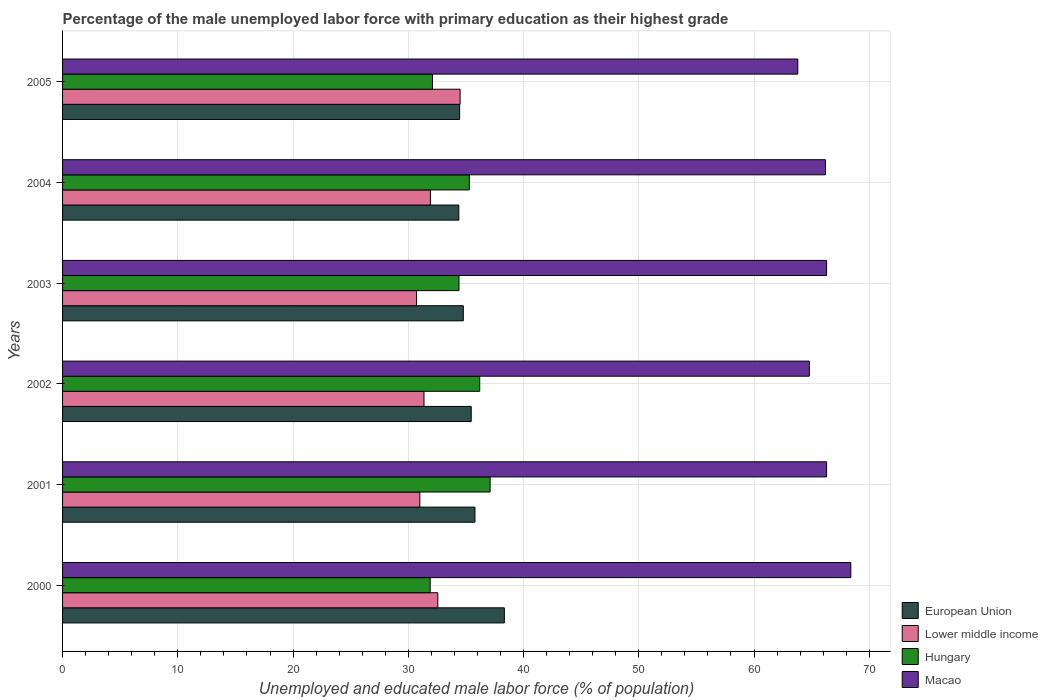How many groups of bars are there?
Keep it short and to the point. 6. Are the number of bars on each tick of the Y-axis equal?
Your response must be concise. Yes. How many bars are there on the 5th tick from the top?
Keep it short and to the point. 4. How many bars are there on the 3rd tick from the bottom?
Give a very brief answer. 4. What is the percentage of the unemployed male labor force with primary education in Hungary in 2000?
Provide a short and direct response. 31.9. Across all years, what is the maximum percentage of the unemployed male labor force with primary education in Macao?
Offer a terse response. 68.4. Across all years, what is the minimum percentage of the unemployed male labor force with primary education in Hungary?
Keep it short and to the point. 31.9. In which year was the percentage of the unemployed male labor force with primary education in Hungary maximum?
Ensure brevity in your answer.  2001. In which year was the percentage of the unemployed male labor force with primary education in Lower middle income minimum?
Offer a very short reply. 2003. What is the total percentage of the unemployed male labor force with primary education in Hungary in the graph?
Ensure brevity in your answer.  207. What is the difference between the percentage of the unemployed male labor force with primary education in Hungary in 2002 and that in 2004?
Give a very brief answer. 0.9. What is the difference between the percentage of the unemployed male labor force with primary education in Lower middle income in 2000 and the percentage of the unemployed male labor force with primary education in Hungary in 2003?
Your response must be concise. -1.84. What is the average percentage of the unemployed male labor force with primary education in Macao per year?
Your response must be concise. 65.97. In the year 2001, what is the difference between the percentage of the unemployed male labor force with primary education in European Union and percentage of the unemployed male labor force with primary education in Macao?
Provide a succinct answer. -30.51. What is the ratio of the percentage of the unemployed male labor force with primary education in Hungary in 2000 to that in 2005?
Your response must be concise. 0.99. What is the difference between the highest and the second highest percentage of the unemployed male labor force with primary education in Macao?
Give a very brief answer. 2.1. What is the difference between the highest and the lowest percentage of the unemployed male labor force with primary education in Hungary?
Provide a succinct answer. 5.2. In how many years, is the percentage of the unemployed male labor force with primary education in European Union greater than the average percentage of the unemployed male labor force with primary education in European Union taken over all years?
Offer a very short reply. 2. Is it the case that in every year, the sum of the percentage of the unemployed male labor force with primary education in European Union and percentage of the unemployed male labor force with primary education in Macao is greater than the sum of percentage of the unemployed male labor force with primary education in Lower middle income and percentage of the unemployed male labor force with primary education in Hungary?
Your answer should be compact. No. What does the 3rd bar from the top in 2000 represents?
Your answer should be very brief. Lower middle income. What does the 4th bar from the bottom in 2004 represents?
Keep it short and to the point. Macao. Are all the bars in the graph horizontal?
Give a very brief answer. Yes. How many years are there in the graph?
Give a very brief answer. 6. Are the values on the major ticks of X-axis written in scientific E-notation?
Keep it short and to the point. No. What is the title of the graph?
Your response must be concise. Percentage of the male unemployed labor force with primary education as their highest grade. Does "Niger" appear as one of the legend labels in the graph?
Your answer should be compact. No. What is the label or title of the X-axis?
Your answer should be very brief. Unemployed and educated male labor force (% of population). What is the label or title of the Y-axis?
Your response must be concise. Years. What is the Unemployed and educated male labor force (% of population) of European Union in 2000?
Your answer should be very brief. 38.34. What is the Unemployed and educated male labor force (% of population) of Lower middle income in 2000?
Provide a succinct answer. 32.56. What is the Unemployed and educated male labor force (% of population) of Hungary in 2000?
Your response must be concise. 31.9. What is the Unemployed and educated male labor force (% of population) in Macao in 2000?
Give a very brief answer. 68.4. What is the Unemployed and educated male labor force (% of population) of European Union in 2001?
Give a very brief answer. 35.79. What is the Unemployed and educated male labor force (% of population) of Lower middle income in 2001?
Keep it short and to the point. 31. What is the Unemployed and educated male labor force (% of population) of Hungary in 2001?
Make the answer very short. 37.1. What is the Unemployed and educated male labor force (% of population) in Macao in 2001?
Ensure brevity in your answer.  66.3. What is the Unemployed and educated male labor force (% of population) in European Union in 2002?
Your answer should be compact. 35.46. What is the Unemployed and educated male labor force (% of population) of Lower middle income in 2002?
Ensure brevity in your answer.  31.36. What is the Unemployed and educated male labor force (% of population) in Hungary in 2002?
Keep it short and to the point. 36.2. What is the Unemployed and educated male labor force (% of population) in Macao in 2002?
Your response must be concise. 64.8. What is the Unemployed and educated male labor force (% of population) in European Union in 2003?
Offer a very short reply. 34.77. What is the Unemployed and educated male labor force (% of population) of Lower middle income in 2003?
Your answer should be compact. 30.72. What is the Unemployed and educated male labor force (% of population) of Hungary in 2003?
Keep it short and to the point. 34.4. What is the Unemployed and educated male labor force (% of population) in Macao in 2003?
Ensure brevity in your answer.  66.3. What is the Unemployed and educated male labor force (% of population) of European Union in 2004?
Offer a very short reply. 34.39. What is the Unemployed and educated male labor force (% of population) of Lower middle income in 2004?
Ensure brevity in your answer.  31.92. What is the Unemployed and educated male labor force (% of population) in Hungary in 2004?
Your answer should be very brief. 35.3. What is the Unemployed and educated male labor force (% of population) of Macao in 2004?
Provide a short and direct response. 66.2. What is the Unemployed and educated male labor force (% of population) in European Union in 2005?
Ensure brevity in your answer.  34.46. What is the Unemployed and educated male labor force (% of population) in Lower middle income in 2005?
Offer a terse response. 34.5. What is the Unemployed and educated male labor force (% of population) in Hungary in 2005?
Keep it short and to the point. 32.1. What is the Unemployed and educated male labor force (% of population) in Macao in 2005?
Your answer should be very brief. 63.8. Across all years, what is the maximum Unemployed and educated male labor force (% of population) in European Union?
Your answer should be compact. 38.34. Across all years, what is the maximum Unemployed and educated male labor force (% of population) in Lower middle income?
Keep it short and to the point. 34.5. Across all years, what is the maximum Unemployed and educated male labor force (% of population) in Hungary?
Provide a succinct answer. 37.1. Across all years, what is the maximum Unemployed and educated male labor force (% of population) of Macao?
Make the answer very short. 68.4. Across all years, what is the minimum Unemployed and educated male labor force (% of population) in European Union?
Your response must be concise. 34.39. Across all years, what is the minimum Unemployed and educated male labor force (% of population) of Lower middle income?
Offer a very short reply. 30.72. Across all years, what is the minimum Unemployed and educated male labor force (% of population) in Hungary?
Your response must be concise. 31.9. Across all years, what is the minimum Unemployed and educated male labor force (% of population) of Macao?
Your response must be concise. 63.8. What is the total Unemployed and educated male labor force (% of population) in European Union in the graph?
Keep it short and to the point. 213.2. What is the total Unemployed and educated male labor force (% of population) of Lower middle income in the graph?
Provide a short and direct response. 192.05. What is the total Unemployed and educated male labor force (% of population) in Hungary in the graph?
Give a very brief answer. 207. What is the total Unemployed and educated male labor force (% of population) of Macao in the graph?
Give a very brief answer. 395.8. What is the difference between the Unemployed and educated male labor force (% of population) of European Union in 2000 and that in 2001?
Your answer should be compact. 2.55. What is the difference between the Unemployed and educated male labor force (% of population) of Lower middle income in 2000 and that in 2001?
Provide a short and direct response. 1.56. What is the difference between the Unemployed and educated male labor force (% of population) of Hungary in 2000 and that in 2001?
Provide a short and direct response. -5.2. What is the difference between the Unemployed and educated male labor force (% of population) in European Union in 2000 and that in 2002?
Keep it short and to the point. 2.88. What is the difference between the Unemployed and educated male labor force (% of population) of Lower middle income in 2000 and that in 2002?
Give a very brief answer. 1.2. What is the difference between the Unemployed and educated male labor force (% of population) in Macao in 2000 and that in 2002?
Give a very brief answer. 3.6. What is the difference between the Unemployed and educated male labor force (% of population) in European Union in 2000 and that in 2003?
Make the answer very short. 3.56. What is the difference between the Unemployed and educated male labor force (% of population) in Lower middle income in 2000 and that in 2003?
Your answer should be compact. 1.84. What is the difference between the Unemployed and educated male labor force (% of population) of European Union in 2000 and that in 2004?
Make the answer very short. 3.95. What is the difference between the Unemployed and educated male labor force (% of population) of Lower middle income in 2000 and that in 2004?
Give a very brief answer. 0.64. What is the difference between the Unemployed and educated male labor force (% of population) of Hungary in 2000 and that in 2004?
Offer a very short reply. -3.4. What is the difference between the Unemployed and educated male labor force (% of population) in European Union in 2000 and that in 2005?
Keep it short and to the point. 3.88. What is the difference between the Unemployed and educated male labor force (% of population) of Lower middle income in 2000 and that in 2005?
Your response must be concise. -1.94. What is the difference between the Unemployed and educated male labor force (% of population) in Hungary in 2000 and that in 2005?
Keep it short and to the point. -0.2. What is the difference between the Unemployed and educated male labor force (% of population) of Macao in 2000 and that in 2005?
Your answer should be compact. 4.6. What is the difference between the Unemployed and educated male labor force (% of population) of European Union in 2001 and that in 2002?
Make the answer very short. 0.32. What is the difference between the Unemployed and educated male labor force (% of population) of Lower middle income in 2001 and that in 2002?
Provide a short and direct response. -0.36. What is the difference between the Unemployed and educated male labor force (% of population) in European Union in 2001 and that in 2003?
Your answer should be compact. 1.01. What is the difference between the Unemployed and educated male labor force (% of population) in Lower middle income in 2001 and that in 2003?
Your answer should be very brief. 0.28. What is the difference between the Unemployed and educated male labor force (% of population) in Macao in 2001 and that in 2003?
Keep it short and to the point. 0. What is the difference between the Unemployed and educated male labor force (% of population) in European Union in 2001 and that in 2004?
Make the answer very short. 1.4. What is the difference between the Unemployed and educated male labor force (% of population) in Lower middle income in 2001 and that in 2004?
Your answer should be compact. -0.92. What is the difference between the Unemployed and educated male labor force (% of population) in Hungary in 2001 and that in 2004?
Offer a terse response. 1.8. What is the difference between the Unemployed and educated male labor force (% of population) of European Union in 2001 and that in 2005?
Provide a short and direct response. 1.33. What is the difference between the Unemployed and educated male labor force (% of population) of Lower middle income in 2001 and that in 2005?
Provide a succinct answer. -3.49. What is the difference between the Unemployed and educated male labor force (% of population) of Hungary in 2001 and that in 2005?
Keep it short and to the point. 5. What is the difference between the Unemployed and educated male labor force (% of population) of Macao in 2001 and that in 2005?
Make the answer very short. 2.5. What is the difference between the Unemployed and educated male labor force (% of population) in European Union in 2002 and that in 2003?
Your answer should be very brief. 0.69. What is the difference between the Unemployed and educated male labor force (% of population) in Lower middle income in 2002 and that in 2003?
Make the answer very short. 0.65. What is the difference between the Unemployed and educated male labor force (% of population) of European Union in 2002 and that in 2004?
Give a very brief answer. 1.08. What is the difference between the Unemployed and educated male labor force (% of population) in Lower middle income in 2002 and that in 2004?
Your answer should be compact. -0.56. What is the difference between the Unemployed and educated male labor force (% of population) of European Union in 2002 and that in 2005?
Your response must be concise. 1.01. What is the difference between the Unemployed and educated male labor force (% of population) in Lower middle income in 2002 and that in 2005?
Give a very brief answer. -3.13. What is the difference between the Unemployed and educated male labor force (% of population) of Hungary in 2002 and that in 2005?
Provide a succinct answer. 4.1. What is the difference between the Unemployed and educated male labor force (% of population) in European Union in 2003 and that in 2004?
Make the answer very short. 0.39. What is the difference between the Unemployed and educated male labor force (% of population) of Lower middle income in 2003 and that in 2004?
Ensure brevity in your answer.  -1.2. What is the difference between the Unemployed and educated male labor force (% of population) of Hungary in 2003 and that in 2004?
Your response must be concise. -0.9. What is the difference between the Unemployed and educated male labor force (% of population) of Macao in 2003 and that in 2004?
Your answer should be very brief. 0.1. What is the difference between the Unemployed and educated male labor force (% of population) in European Union in 2003 and that in 2005?
Ensure brevity in your answer.  0.32. What is the difference between the Unemployed and educated male labor force (% of population) in Lower middle income in 2003 and that in 2005?
Your answer should be very brief. -3.78. What is the difference between the Unemployed and educated male labor force (% of population) of Macao in 2003 and that in 2005?
Keep it short and to the point. 2.5. What is the difference between the Unemployed and educated male labor force (% of population) of European Union in 2004 and that in 2005?
Offer a terse response. -0.07. What is the difference between the Unemployed and educated male labor force (% of population) of Lower middle income in 2004 and that in 2005?
Give a very brief answer. -2.58. What is the difference between the Unemployed and educated male labor force (% of population) of Hungary in 2004 and that in 2005?
Provide a succinct answer. 3.2. What is the difference between the Unemployed and educated male labor force (% of population) of European Union in 2000 and the Unemployed and educated male labor force (% of population) of Lower middle income in 2001?
Your response must be concise. 7.34. What is the difference between the Unemployed and educated male labor force (% of population) of European Union in 2000 and the Unemployed and educated male labor force (% of population) of Hungary in 2001?
Your answer should be compact. 1.24. What is the difference between the Unemployed and educated male labor force (% of population) in European Union in 2000 and the Unemployed and educated male labor force (% of population) in Macao in 2001?
Keep it short and to the point. -27.96. What is the difference between the Unemployed and educated male labor force (% of population) of Lower middle income in 2000 and the Unemployed and educated male labor force (% of population) of Hungary in 2001?
Give a very brief answer. -4.54. What is the difference between the Unemployed and educated male labor force (% of population) in Lower middle income in 2000 and the Unemployed and educated male labor force (% of population) in Macao in 2001?
Give a very brief answer. -33.74. What is the difference between the Unemployed and educated male labor force (% of population) in Hungary in 2000 and the Unemployed and educated male labor force (% of population) in Macao in 2001?
Make the answer very short. -34.4. What is the difference between the Unemployed and educated male labor force (% of population) in European Union in 2000 and the Unemployed and educated male labor force (% of population) in Lower middle income in 2002?
Provide a succinct answer. 6.97. What is the difference between the Unemployed and educated male labor force (% of population) of European Union in 2000 and the Unemployed and educated male labor force (% of population) of Hungary in 2002?
Provide a succinct answer. 2.14. What is the difference between the Unemployed and educated male labor force (% of population) of European Union in 2000 and the Unemployed and educated male labor force (% of population) of Macao in 2002?
Your answer should be compact. -26.46. What is the difference between the Unemployed and educated male labor force (% of population) of Lower middle income in 2000 and the Unemployed and educated male labor force (% of population) of Hungary in 2002?
Your answer should be compact. -3.64. What is the difference between the Unemployed and educated male labor force (% of population) of Lower middle income in 2000 and the Unemployed and educated male labor force (% of population) of Macao in 2002?
Your answer should be very brief. -32.24. What is the difference between the Unemployed and educated male labor force (% of population) in Hungary in 2000 and the Unemployed and educated male labor force (% of population) in Macao in 2002?
Provide a short and direct response. -32.9. What is the difference between the Unemployed and educated male labor force (% of population) in European Union in 2000 and the Unemployed and educated male labor force (% of population) in Lower middle income in 2003?
Your answer should be very brief. 7.62. What is the difference between the Unemployed and educated male labor force (% of population) of European Union in 2000 and the Unemployed and educated male labor force (% of population) of Hungary in 2003?
Offer a very short reply. 3.94. What is the difference between the Unemployed and educated male labor force (% of population) in European Union in 2000 and the Unemployed and educated male labor force (% of population) in Macao in 2003?
Your response must be concise. -27.96. What is the difference between the Unemployed and educated male labor force (% of population) in Lower middle income in 2000 and the Unemployed and educated male labor force (% of population) in Hungary in 2003?
Offer a very short reply. -1.84. What is the difference between the Unemployed and educated male labor force (% of population) of Lower middle income in 2000 and the Unemployed and educated male labor force (% of population) of Macao in 2003?
Give a very brief answer. -33.74. What is the difference between the Unemployed and educated male labor force (% of population) of Hungary in 2000 and the Unemployed and educated male labor force (% of population) of Macao in 2003?
Your answer should be compact. -34.4. What is the difference between the Unemployed and educated male labor force (% of population) of European Union in 2000 and the Unemployed and educated male labor force (% of population) of Lower middle income in 2004?
Your answer should be compact. 6.42. What is the difference between the Unemployed and educated male labor force (% of population) in European Union in 2000 and the Unemployed and educated male labor force (% of population) in Hungary in 2004?
Your response must be concise. 3.04. What is the difference between the Unemployed and educated male labor force (% of population) of European Union in 2000 and the Unemployed and educated male labor force (% of population) of Macao in 2004?
Your answer should be very brief. -27.86. What is the difference between the Unemployed and educated male labor force (% of population) in Lower middle income in 2000 and the Unemployed and educated male labor force (% of population) in Hungary in 2004?
Your response must be concise. -2.74. What is the difference between the Unemployed and educated male labor force (% of population) in Lower middle income in 2000 and the Unemployed and educated male labor force (% of population) in Macao in 2004?
Make the answer very short. -33.64. What is the difference between the Unemployed and educated male labor force (% of population) of Hungary in 2000 and the Unemployed and educated male labor force (% of population) of Macao in 2004?
Provide a succinct answer. -34.3. What is the difference between the Unemployed and educated male labor force (% of population) in European Union in 2000 and the Unemployed and educated male labor force (% of population) in Lower middle income in 2005?
Ensure brevity in your answer.  3.84. What is the difference between the Unemployed and educated male labor force (% of population) of European Union in 2000 and the Unemployed and educated male labor force (% of population) of Hungary in 2005?
Give a very brief answer. 6.24. What is the difference between the Unemployed and educated male labor force (% of population) of European Union in 2000 and the Unemployed and educated male labor force (% of population) of Macao in 2005?
Make the answer very short. -25.46. What is the difference between the Unemployed and educated male labor force (% of population) in Lower middle income in 2000 and the Unemployed and educated male labor force (% of population) in Hungary in 2005?
Make the answer very short. 0.46. What is the difference between the Unemployed and educated male labor force (% of population) of Lower middle income in 2000 and the Unemployed and educated male labor force (% of population) of Macao in 2005?
Provide a short and direct response. -31.24. What is the difference between the Unemployed and educated male labor force (% of population) of Hungary in 2000 and the Unemployed and educated male labor force (% of population) of Macao in 2005?
Your response must be concise. -31.9. What is the difference between the Unemployed and educated male labor force (% of population) of European Union in 2001 and the Unemployed and educated male labor force (% of population) of Lower middle income in 2002?
Give a very brief answer. 4.42. What is the difference between the Unemployed and educated male labor force (% of population) of European Union in 2001 and the Unemployed and educated male labor force (% of population) of Hungary in 2002?
Provide a succinct answer. -0.41. What is the difference between the Unemployed and educated male labor force (% of population) in European Union in 2001 and the Unemployed and educated male labor force (% of population) in Macao in 2002?
Provide a short and direct response. -29.01. What is the difference between the Unemployed and educated male labor force (% of population) of Lower middle income in 2001 and the Unemployed and educated male labor force (% of population) of Hungary in 2002?
Your answer should be very brief. -5.2. What is the difference between the Unemployed and educated male labor force (% of population) in Lower middle income in 2001 and the Unemployed and educated male labor force (% of population) in Macao in 2002?
Keep it short and to the point. -33.8. What is the difference between the Unemployed and educated male labor force (% of population) in Hungary in 2001 and the Unemployed and educated male labor force (% of population) in Macao in 2002?
Your response must be concise. -27.7. What is the difference between the Unemployed and educated male labor force (% of population) in European Union in 2001 and the Unemployed and educated male labor force (% of population) in Lower middle income in 2003?
Ensure brevity in your answer.  5.07. What is the difference between the Unemployed and educated male labor force (% of population) of European Union in 2001 and the Unemployed and educated male labor force (% of population) of Hungary in 2003?
Your response must be concise. 1.39. What is the difference between the Unemployed and educated male labor force (% of population) in European Union in 2001 and the Unemployed and educated male labor force (% of population) in Macao in 2003?
Give a very brief answer. -30.51. What is the difference between the Unemployed and educated male labor force (% of population) of Lower middle income in 2001 and the Unemployed and educated male labor force (% of population) of Hungary in 2003?
Your answer should be very brief. -3.4. What is the difference between the Unemployed and educated male labor force (% of population) in Lower middle income in 2001 and the Unemployed and educated male labor force (% of population) in Macao in 2003?
Keep it short and to the point. -35.3. What is the difference between the Unemployed and educated male labor force (% of population) in Hungary in 2001 and the Unemployed and educated male labor force (% of population) in Macao in 2003?
Provide a succinct answer. -29.2. What is the difference between the Unemployed and educated male labor force (% of population) in European Union in 2001 and the Unemployed and educated male labor force (% of population) in Lower middle income in 2004?
Offer a terse response. 3.87. What is the difference between the Unemployed and educated male labor force (% of population) in European Union in 2001 and the Unemployed and educated male labor force (% of population) in Hungary in 2004?
Ensure brevity in your answer.  0.49. What is the difference between the Unemployed and educated male labor force (% of population) in European Union in 2001 and the Unemployed and educated male labor force (% of population) in Macao in 2004?
Ensure brevity in your answer.  -30.41. What is the difference between the Unemployed and educated male labor force (% of population) in Lower middle income in 2001 and the Unemployed and educated male labor force (% of population) in Hungary in 2004?
Your response must be concise. -4.3. What is the difference between the Unemployed and educated male labor force (% of population) of Lower middle income in 2001 and the Unemployed and educated male labor force (% of population) of Macao in 2004?
Keep it short and to the point. -35.2. What is the difference between the Unemployed and educated male labor force (% of population) of Hungary in 2001 and the Unemployed and educated male labor force (% of population) of Macao in 2004?
Your answer should be very brief. -29.1. What is the difference between the Unemployed and educated male labor force (% of population) in European Union in 2001 and the Unemployed and educated male labor force (% of population) in Lower middle income in 2005?
Provide a short and direct response. 1.29. What is the difference between the Unemployed and educated male labor force (% of population) of European Union in 2001 and the Unemployed and educated male labor force (% of population) of Hungary in 2005?
Offer a very short reply. 3.69. What is the difference between the Unemployed and educated male labor force (% of population) of European Union in 2001 and the Unemployed and educated male labor force (% of population) of Macao in 2005?
Your answer should be very brief. -28.01. What is the difference between the Unemployed and educated male labor force (% of population) in Lower middle income in 2001 and the Unemployed and educated male labor force (% of population) in Hungary in 2005?
Make the answer very short. -1.1. What is the difference between the Unemployed and educated male labor force (% of population) in Lower middle income in 2001 and the Unemployed and educated male labor force (% of population) in Macao in 2005?
Make the answer very short. -32.8. What is the difference between the Unemployed and educated male labor force (% of population) of Hungary in 2001 and the Unemployed and educated male labor force (% of population) of Macao in 2005?
Your response must be concise. -26.7. What is the difference between the Unemployed and educated male labor force (% of population) of European Union in 2002 and the Unemployed and educated male labor force (% of population) of Lower middle income in 2003?
Make the answer very short. 4.75. What is the difference between the Unemployed and educated male labor force (% of population) in European Union in 2002 and the Unemployed and educated male labor force (% of population) in Hungary in 2003?
Ensure brevity in your answer.  1.06. What is the difference between the Unemployed and educated male labor force (% of population) in European Union in 2002 and the Unemployed and educated male labor force (% of population) in Macao in 2003?
Offer a very short reply. -30.84. What is the difference between the Unemployed and educated male labor force (% of population) in Lower middle income in 2002 and the Unemployed and educated male labor force (% of population) in Hungary in 2003?
Offer a terse response. -3.04. What is the difference between the Unemployed and educated male labor force (% of population) of Lower middle income in 2002 and the Unemployed and educated male labor force (% of population) of Macao in 2003?
Offer a terse response. -34.94. What is the difference between the Unemployed and educated male labor force (% of population) in Hungary in 2002 and the Unemployed and educated male labor force (% of population) in Macao in 2003?
Keep it short and to the point. -30.1. What is the difference between the Unemployed and educated male labor force (% of population) of European Union in 2002 and the Unemployed and educated male labor force (% of population) of Lower middle income in 2004?
Your answer should be compact. 3.54. What is the difference between the Unemployed and educated male labor force (% of population) of European Union in 2002 and the Unemployed and educated male labor force (% of population) of Hungary in 2004?
Ensure brevity in your answer.  0.16. What is the difference between the Unemployed and educated male labor force (% of population) in European Union in 2002 and the Unemployed and educated male labor force (% of population) in Macao in 2004?
Offer a terse response. -30.74. What is the difference between the Unemployed and educated male labor force (% of population) in Lower middle income in 2002 and the Unemployed and educated male labor force (% of population) in Hungary in 2004?
Offer a very short reply. -3.94. What is the difference between the Unemployed and educated male labor force (% of population) in Lower middle income in 2002 and the Unemployed and educated male labor force (% of population) in Macao in 2004?
Make the answer very short. -34.84. What is the difference between the Unemployed and educated male labor force (% of population) of Hungary in 2002 and the Unemployed and educated male labor force (% of population) of Macao in 2004?
Ensure brevity in your answer.  -30. What is the difference between the Unemployed and educated male labor force (% of population) of European Union in 2002 and the Unemployed and educated male labor force (% of population) of Lower middle income in 2005?
Keep it short and to the point. 0.97. What is the difference between the Unemployed and educated male labor force (% of population) of European Union in 2002 and the Unemployed and educated male labor force (% of population) of Hungary in 2005?
Your response must be concise. 3.36. What is the difference between the Unemployed and educated male labor force (% of population) of European Union in 2002 and the Unemployed and educated male labor force (% of population) of Macao in 2005?
Provide a succinct answer. -28.34. What is the difference between the Unemployed and educated male labor force (% of population) of Lower middle income in 2002 and the Unemployed and educated male labor force (% of population) of Hungary in 2005?
Offer a very short reply. -0.74. What is the difference between the Unemployed and educated male labor force (% of population) of Lower middle income in 2002 and the Unemployed and educated male labor force (% of population) of Macao in 2005?
Offer a terse response. -32.44. What is the difference between the Unemployed and educated male labor force (% of population) of Hungary in 2002 and the Unemployed and educated male labor force (% of population) of Macao in 2005?
Keep it short and to the point. -27.6. What is the difference between the Unemployed and educated male labor force (% of population) of European Union in 2003 and the Unemployed and educated male labor force (% of population) of Lower middle income in 2004?
Keep it short and to the point. 2.86. What is the difference between the Unemployed and educated male labor force (% of population) of European Union in 2003 and the Unemployed and educated male labor force (% of population) of Hungary in 2004?
Provide a short and direct response. -0.53. What is the difference between the Unemployed and educated male labor force (% of population) of European Union in 2003 and the Unemployed and educated male labor force (% of population) of Macao in 2004?
Ensure brevity in your answer.  -31.43. What is the difference between the Unemployed and educated male labor force (% of population) of Lower middle income in 2003 and the Unemployed and educated male labor force (% of population) of Hungary in 2004?
Give a very brief answer. -4.58. What is the difference between the Unemployed and educated male labor force (% of population) in Lower middle income in 2003 and the Unemployed and educated male labor force (% of population) in Macao in 2004?
Make the answer very short. -35.48. What is the difference between the Unemployed and educated male labor force (% of population) of Hungary in 2003 and the Unemployed and educated male labor force (% of population) of Macao in 2004?
Give a very brief answer. -31.8. What is the difference between the Unemployed and educated male labor force (% of population) of European Union in 2003 and the Unemployed and educated male labor force (% of population) of Lower middle income in 2005?
Your answer should be compact. 0.28. What is the difference between the Unemployed and educated male labor force (% of population) in European Union in 2003 and the Unemployed and educated male labor force (% of population) in Hungary in 2005?
Give a very brief answer. 2.67. What is the difference between the Unemployed and educated male labor force (% of population) in European Union in 2003 and the Unemployed and educated male labor force (% of population) in Macao in 2005?
Your answer should be very brief. -29.03. What is the difference between the Unemployed and educated male labor force (% of population) of Lower middle income in 2003 and the Unemployed and educated male labor force (% of population) of Hungary in 2005?
Give a very brief answer. -1.38. What is the difference between the Unemployed and educated male labor force (% of population) in Lower middle income in 2003 and the Unemployed and educated male labor force (% of population) in Macao in 2005?
Your response must be concise. -33.08. What is the difference between the Unemployed and educated male labor force (% of population) of Hungary in 2003 and the Unemployed and educated male labor force (% of population) of Macao in 2005?
Ensure brevity in your answer.  -29.4. What is the difference between the Unemployed and educated male labor force (% of population) in European Union in 2004 and the Unemployed and educated male labor force (% of population) in Lower middle income in 2005?
Your answer should be compact. -0.11. What is the difference between the Unemployed and educated male labor force (% of population) in European Union in 2004 and the Unemployed and educated male labor force (% of population) in Hungary in 2005?
Make the answer very short. 2.29. What is the difference between the Unemployed and educated male labor force (% of population) in European Union in 2004 and the Unemployed and educated male labor force (% of population) in Macao in 2005?
Your answer should be very brief. -29.41. What is the difference between the Unemployed and educated male labor force (% of population) in Lower middle income in 2004 and the Unemployed and educated male labor force (% of population) in Hungary in 2005?
Provide a succinct answer. -0.18. What is the difference between the Unemployed and educated male labor force (% of population) of Lower middle income in 2004 and the Unemployed and educated male labor force (% of population) of Macao in 2005?
Ensure brevity in your answer.  -31.88. What is the difference between the Unemployed and educated male labor force (% of population) of Hungary in 2004 and the Unemployed and educated male labor force (% of population) of Macao in 2005?
Your answer should be very brief. -28.5. What is the average Unemployed and educated male labor force (% of population) in European Union per year?
Offer a terse response. 35.53. What is the average Unemployed and educated male labor force (% of population) in Lower middle income per year?
Make the answer very short. 32.01. What is the average Unemployed and educated male labor force (% of population) of Hungary per year?
Your answer should be very brief. 34.5. What is the average Unemployed and educated male labor force (% of population) in Macao per year?
Your answer should be very brief. 65.97. In the year 2000, what is the difference between the Unemployed and educated male labor force (% of population) of European Union and Unemployed and educated male labor force (% of population) of Lower middle income?
Make the answer very short. 5.78. In the year 2000, what is the difference between the Unemployed and educated male labor force (% of population) of European Union and Unemployed and educated male labor force (% of population) of Hungary?
Provide a short and direct response. 6.44. In the year 2000, what is the difference between the Unemployed and educated male labor force (% of population) of European Union and Unemployed and educated male labor force (% of population) of Macao?
Give a very brief answer. -30.06. In the year 2000, what is the difference between the Unemployed and educated male labor force (% of population) in Lower middle income and Unemployed and educated male labor force (% of population) in Hungary?
Your response must be concise. 0.66. In the year 2000, what is the difference between the Unemployed and educated male labor force (% of population) in Lower middle income and Unemployed and educated male labor force (% of population) in Macao?
Offer a very short reply. -35.84. In the year 2000, what is the difference between the Unemployed and educated male labor force (% of population) of Hungary and Unemployed and educated male labor force (% of population) of Macao?
Give a very brief answer. -36.5. In the year 2001, what is the difference between the Unemployed and educated male labor force (% of population) in European Union and Unemployed and educated male labor force (% of population) in Lower middle income?
Offer a very short reply. 4.78. In the year 2001, what is the difference between the Unemployed and educated male labor force (% of population) in European Union and Unemployed and educated male labor force (% of population) in Hungary?
Give a very brief answer. -1.31. In the year 2001, what is the difference between the Unemployed and educated male labor force (% of population) of European Union and Unemployed and educated male labor force (% of population) of Macao?
Give a very brief answer. -30.51. In the year 2001, what is the difference between the Unemployed and educated male labor force (% of population) in Lower middle income and Unemployed and educated male labor force (% of population) in Hungary?
Offer a terse response. -6.1. In the year 2001, what is the difference between the Unemployed and educated male labor force (% of population) of Lower middle income and Unemployed and educated male labor force (% of population) of Macao?
Make the answer very short. -35.3. In the year 2001, what is the difference between the Unemployed and educated male labor force (% of population) of Hungary and Unemployed and educated male labor force (% of population) of Macao?
Give a very brief answer. -29.2. In the year 2002, what is the difference between the Unemployed and educated male labor force (% of population) in European Union and Unemployed and educated male labor force (% of population) in Lower middle income?
Offer a very short reply. 4.1. In the year 2002, what is the difference between the Unemployed and educated male labor force (% of population) of European Union and Unemployed and educated male labor force (% of population) of Hungary?
Your answer should be compact. -0.74. In the year 2002, what is the difference between the Unemployed and educated male labor force (% of population) in European Union and Unemployed and educated male labor force (% of population) in Macao?
Give a very brief answer. -29.34. In the year 2002, what is the difference between the Unemployed and educated male labor force (% of population) in Lower middle income and Unemployed and educated male labor force (% of population) in Hungary?
Offer a very short reply. -4.84. In the year 2002, what is the difference between the Unemployed and educated male labor force (% of population) of Lower middle income and Unemployed and educated male labor force (% of population) of Macao?
Offer a very short reply. -33.44. In the year 2002, what is the difference between the Unemployed and educated male labor force (% of population) in Hungary and Unemployed and educated male labor force (% of population) in Macao?
Your response must be concise. -28.6. In the year 2003, what is the difference between the Unemployed and educated male labor force (% of population) in European Union and Unemployed and educated male labor force (% of population) in Lower middle income?
Make the answer very short. 4.06. In the year 2003, what is the difference between the Unemployed and educated male labor force (% of population) in European Union and Unemployed and educated male labor force (% of population) in Hungary?
Provide a succinct answer. 0.37. In the year 2003, what is the difference between the Unemployed and educated male labor force (% of population) in European Union and Unemployed and educated male labor force (% of population) in Macao?
Your answer should be very brief. -31.53. In the year 2003, what is the difference between the Unemployed and educated male labor force (% of population) of Lower middle income and Unemployed and educated male labor force (% of population) of Hungary?
Make the answer very short. -3.68. In the year 2003, what is the difference between the Unemployed and educated male labor force (% of population) of Lower middle income and Unemployed and educated male labor force (% of population) of Macao?
Offer a terse response. -35.58. In the year 2003, what is the difference between the Unemployed and educated male labor force (% of population) of Hungary and Unemployed and educated male labor force (% of population) of Macao?
Provide a succinct answer. -31.9. In the year 2004, what is the difference between the Unemployed and educated male labor force (% of population) of European Union and Unemployed and educated male labor force (% of population) of Lower middle income?
Ensure brevity in your answer.  2.47. In the year 2004, what is the difference between the Unemployed and educated male labor force (% of population) in European Union and Unemployed and educated male labor force (% of population) in Hungary?
Your answer should be very brief. -0.91. In the year 2004, what is the difference between the Unemployed and educated male labor force (% of population) of European Union and Unemployed and educated male labor force (% of population) of Macao?
Offer a terse response. -31.81. In the year 2004, what is the difference between the Unemployed and educated male labor force (% of population) in Lower middle income and Unemployed and educated male labor force (% of population) in Hungary?
Keep it short and to the point. -3.38. In the year 2004, what is the difference between the Unemployed and educated male labor force (% of population) in Lower middle income and Unemployed and educated male labor force (% of population) in Macao?
Your response must be concise. -34.28. In the year 2004, what is the difference between the Unemployed and educated male labor force (% of population) in Hungary and Unemployed and educated male labor force (% of population) in Macao?
Offer a very short reply. -30.9. In the year 2005, what is the difference between the Unemployed and educated male labor force (% of population) of European Union and Unemployed and educated male labor force (% of population) of Lower middle income?
Provide a succinct answer. -0.04. In the year 2005, what is the difference between the Unemployed and educated male labor force (% of population) of European Union and Unemployed and educated male labor force (% of population) of Hungary?
Provide a succinct answer. 2.36. In the year 2005, what is the difference between the Unemployed and educated male labor force (% of population) of European Union and Unemployed and educated male labor force (% of population) of Macao?
Keep it short and to the point. -29.34. In the year 2005, what is the difference between the Unemployed and educated male labor force (% of population) in Lower middle income and Unemployed and educated male labor force (% of population) in Hungary?
Keep it short and to the point. 2.4. In the year 2005, what is the difference between the Unemployed and educated male labor force (% of population) of Lower middle income and Unemployed and educated male labor force (% of population) of Macao?
Give a very brief answer. -29.3. In the year 2005, what is the difference between the Unemployed and educated male labor force (% of population) in Hungary and Unemployed and educated male labor force (% of population) in Macao?
Provide a succinct answer. -31.7. What is the ratio of the Unemployed and educated male labor force (% of population) of European Union in 2000 to that in 2001?
Offer a terse response. 1.07. What is the ratio of the Unemployed and educated male labor force (% of population) of Lower middle income in 2000 to that in 2001?
Provide a succinct answer. 1.05. What is the ratio of the Unemployed and educated male labor force (% of population) in Hungary in 2000 to that in 2001?
Make the answer very short. 0.86. What is the ratio of the Unemployed and educated male labor force (% of population) in Macao in 2000 to that in 2001?
Ensure brevity in your answer.  1.03. What is the ratio of the Unemployed and educated male labor force (% of population) in European Union in 2000 to that in 2002?
Offer a terse response. 1.08. What is the ratio of the Unemployed and educated male labor force (% of population) of Lower middle income in 2000 to that in 2002?
Make the answer very short. 1.04. What is the ratio of the Unemployed and educated male labor force (% of population) of Hungary in 2000 to that in 2002?
Keep it short and to the point. 0.88. What is the ratio of the Unemployed and educated male labor force (% of population) of Macao in 2000 to that in 2002?
Give a very brief answer. 1.06. What is the ratio of the Unemployed and educated male labor force (% of population) of European Union in 2000 to that in 2003?
Ensure brevity in your answer.  1.1. What is the ratio of the Unemployed and educated male labor force (% of population) in Lower middle income in 2000 to that in 2003?
Your response must be concise. 1.06. What is the ratio of the Unemployed and educated male labor force (% of population) in Hungary in 2000 to that in 2003?
Make the answer very short. 0.93. What is the ratio of the Unemployed and educated male labor force (% of population) in Macao in 2000 to that in 2003?
Offer a terse response. 1.03. What is the ratio of the Unemployed and educated male labor force (% of population) of European Union in 2000 to that in 2004?
Provide a succinct answer. 1.11. What is the ratio of the Unemployed and educated male labor force (% of population) in Lower middle income in 2000 to that in 2004?
Your response must be concise. 1.02. What is the ratio of the Unemployed and educated male labor force (% of population) in Hungary in 2000 to that in 2004?
Your answer should be very brief. 0.9. What is the ratio of the Unemployed and educated male labor force (% of population) of Macao in 2000 to that in 2004?
Your answer should be very brief. 1.03. What is the ratio of the Unemployed and educated male labor force (% of population) of European Union in 2000 to that in 2005?
Give a very brief answer. 1.11. What is the ratio of the Unemployed and educated male labor force (% of population) of Lower middle income in 2000 to that in 2005?
Your answer should be compact. 0.94. What is the ratio of the Unemployed and educated male labor force (% of population) in Hungary in 2000 to that in 2005?
Provide a succinct answer. 0.99. What is the ratio of the Unemployed and educated male labor force (% of population) of Macao in 2000 to that in 2005?
Your response must be concise. 1.07. What is the ratio of the Unemployed and educated male labor force (% of population) of European Union in 2001 to that in 2002?
Provide a succinct answer. 1.01. What is the ratio of the Unemployed and educated male labor force (% of population) of Hungary in 2001 to that in 2002?
Provide a succinct answer. 1.02. What is the ratio of the Unemployed and educated male labor force (% of population) in Macao in 2001 to that in 2002?
Keep it short and to the point. 1.02. What is the ratio of the Unemployed and educated male labor force (% of population) in European Union in 2001 to that in 2003?
Provide a succinct answer. 1.03. What is the ratio of the Unemployed and educated male labor force (% of population) of Lower middle income in 2001 to that in 2003?
Provide a succinct answer. 1.01. What is the ratio of the Unemployed and educated male labor force (% of population) of Hungary in 2001 to that in 2003?
Offer a terse response. 1.08. What is the ratio of the Unemployed and educated male labor force (% of population) of Macao in 2001 to that in 2003?
Your response must be concise. 1. What is the ratio of the Unemployed and educated male labor force (% of population) of European Union in 2001 to that in 2004?
Ensure brevity in your answer.  1.04. What is the ratio of the Unemployed and educated male labor force (% of population) of Lower middle income in 2001 to that in 2004?
Your answer should be compact. 0.97. What is the ratio of the Unemployed and educated male labor force (% of population) in Hungary in 2001 to that in 2004?
Your answer should be compact. 1.05. What is the ratio of the Unemployed and educated male labor force (% of population) of Macao in 2001 to that in 2004?
Your answer should be very brief. 1. What is the ratio of the Unemployed and educated male labor force (% of population) in European Union in 2001 to that in 2005?
Your answer should be very brief. 1.04. What is the ratio of the Unemployed and educated male labor force (% of population) of Lower middle income in 2001 to that in 2005?
Offer a terse response. 0.9. What is the ratio of the Unemployed and educated male labor force (% of population) of Hungary in 2001 to that in 2005?
Your answer should be very brief. 1.16. What is the ratio of the Unemployed and educated male labor force (% of population) in Macao in 2001 to that in 2005?
Offer a very short reply. 1.04. What is the ratio of the Unemployed and educated male labor force (% of population) in European Union in 2002 to that in 2003?
Offer a very short reply. 1.02. What is the ratio of the Unemployed and educated male labor force (% of population) in Hungary in 2002 to that in 2003?
Make the answer very short. 1.05. What is the ratio of the Unemployed and educated male labor force (% of population) in Macao in 2002 to that in 2003?
Give a very brief answer. 0.98. What is the ratio of the Unemployed and educated male labor force (% of population) in European Union in 2002 to that in 2004?
Your answer should be compact. 1.03. What is the ratio of the Unemployed and educated male labor force (% of population) in Lower middle income in 2002 to that in 2004?
Ensure brevity in your answer.  0.98. What is the ratio of the Unemployed and educated male labor force (% of population) of Hungary in 2002 to that in 2004?
Your answer should be very brief. 1.03. What is the ratio of the Unemployed and educated male labor force (% of population) in Macao in 2002 to that in 2004?
Keep it short and to the point. 0.98. What is the ratio of the Unemployed and educated male labor force (% of population) in European Union in 2002 to that in 2005?
Provide a succinct answer. 1.03. What is the ratio of the Unemployed and educated male labor force (% of population) in Lower middle income in 2002 to that in 2005?
Provide a succinct answer. 0.91. What is the ratio of the Unemployed and educated male labor force (% of population) in Hungary in 2002 to that in 2005?
Keep it short and to the point. 1.13. What is the ratio of the Unemployed and educated male labor force (% of population) of Macao in 2002 to that in 2005?
Give a very brief answer. 1.02. What is the ratio of the Unemployed and educated male labor force (% of population) of European Union in 2003 to that in 2004?
Provide a succinct answer. 1.01. What is the ratio of the Unemployed and educated male labor force (% of population) in Lower middle income in 2003 to that in 2004?
Keep it short and to the point. 0.96. What is the ratio of the Unemployed and educated male labor force (% of population) of Hungary in 2003 to that in 2004?
Keep it short and to the point. 0.97. What is the ratio of the Unemployed and educated male labor force (% of population) of Macao in 2003 to that in 2004?
Offer a very short reply. 1. What is the ratio of the Unemployed and educated male labor force (% of population) in European Union in 2003 to that in 2005?
Make the answer very short. 1.01. What is the ratio of the Unemployed and educated male labor force (% of population) of Lower middle income in 2003 to that in 2005?
Offer a very short reply. 0.89. What is the ratio of the Unemployed and educated male labor force (% of population) in Hungary in 2003 to that in 2005?
Keep it short and to the point. 1.07. What is the ratio of the Unemployed and educated male labor force (% of population) of Macao in 2003 to that in 2005?
Offer a very short reply. 1.04. What is the ratio of the Unemployed and educated male labor force (% of population) of European Union in 2004 to that in 2005?
Provide a succinct answer. 1. What is the ratio of the Unemployed and educated male labor force (% of population) in Lower middle income in 2004 to that in 2005?
Keep it short and to the point. 0.93. What is the ratio of the Unemployed and educated male labor force (% of population) in Hungary in 2004 to that in 2005?
Ensure brevity in your answer.  1.1. What is the ratio of the Unemployed and educated male labor force (% of population) in Macao in 2004 to that in 2005?
Give a very brief answer. 1.04. What is the difference between the highest and the second highest Unemployed and educated male labor force (% of population) in European Union?
Offer a very short reply. 2.55. What is the difference between the highest and the second highest Unemployed and educated male labor force (% of population) of Lower middle income?
Your answer should be very brief. 1.94. What is the difference between the highest and the second highest Unemployed and educated male labor force (% of population) of Hungary?
Make the answer very short. 0.9. What is the difference between the highest and the second highest Unemployed and educated male labor force (% of population) in Macao?
Keep it short and to the point. 2.1. What is the difference between the highest and the lowest Unemployed and educated male labor force (% of population) in European Union?
Provide a succinct answer. 3.95. What is the difference between the highest and the lowest Unemployed and educated male labor force (% of population) of Lower middle income?
Provide a short and direct response. 3.78. What is the difference between the highest and the lowest Unemployed and educated male labor force (% of population) in Macao?
Your answer should be very brief. 4.6. 